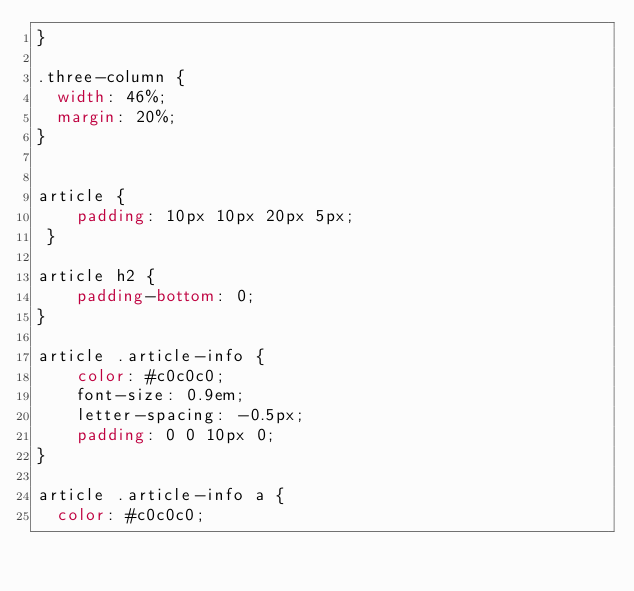<code> <loc_0><loc_0><loc_500><loc_500><_CSS_>}

.three-column {
	width: 46%;
	margin: 20%;
}


article {
    padding: 10px 10px 20px 5px;
 }

article h2 {
    padding-bottom: 0;
}

article .article-info {
    color: #c0c0c0;
    font-size: 0.9em;
    letter-spacing: -0.5px;
    padding: 0 0 10px 0;
}

article .article-info a { 
	color: #c0c0c0;</code> 